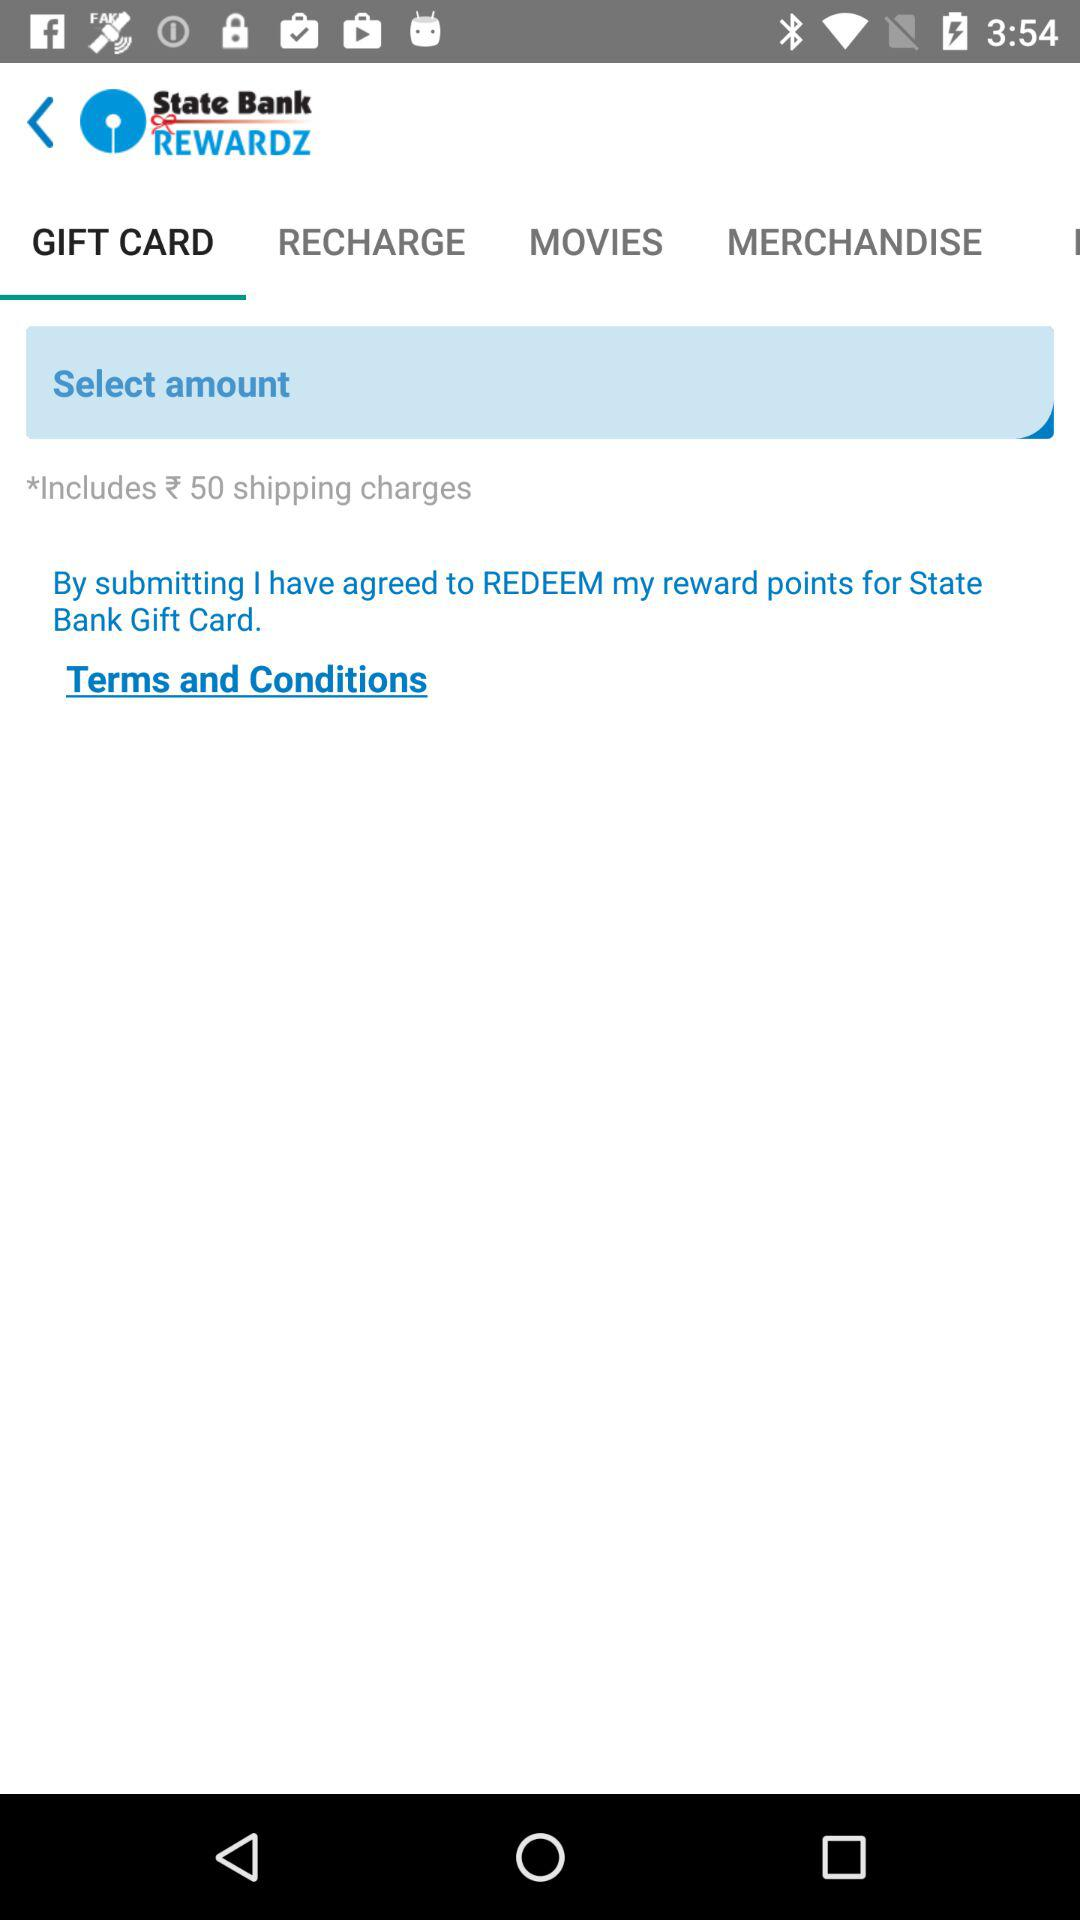How much will the shipping charges be for my gift card?
Answer the question using a single word or phrase. 50 